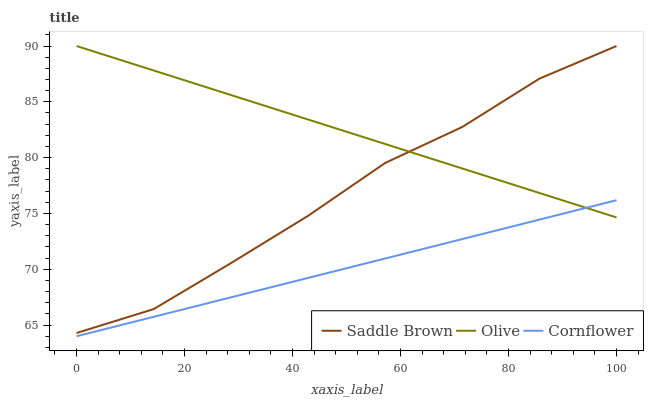Does Cornflower have the minimum area under the curve?
Answer yes or no. Yes. Does Olive have the maximum area under the curve?
Answer yes or no. Yes. Does Saddle Brown have the minimum area under the curve?
Answer yes or no. No. Does Saddle Brown have the maximum area under the curve?
Answer yes or no. No. Is Cornflower the smoothest?
Answer yes or no. Yes. Is Saddle Brown the roughest?
Answer yes or no. Yes. Is Saddle Brown the smoothest?
Answer yes or no. No. Is Cornflower the roughest?
Answer yes or no. No. Does Cornflower have the lowest value?
Answer yes or no. Yes. Does Saddle Brown have the lowest value?
Answer yes or no. No. Does Saddle Brown have the highest value?
Answer yes or no. Yes. Does Cornflower have the highest value?
Answer yes or no. No. Is Cornflower less than Saddle Brown?
Answer yes or no. Yes. Is Saddle Brown greater than Cornflower?
Answer yes or no. Yes. Does Olive intersect Cornflower?
Answer yes or no. Yes. Is Olive less than Cornflower?
Answer yes or no. No. Is Olive greater than Cornflower?
Answer yes or no. No. Does Cornflower intersect Saddle Brown?
Answer yes or no. No. 